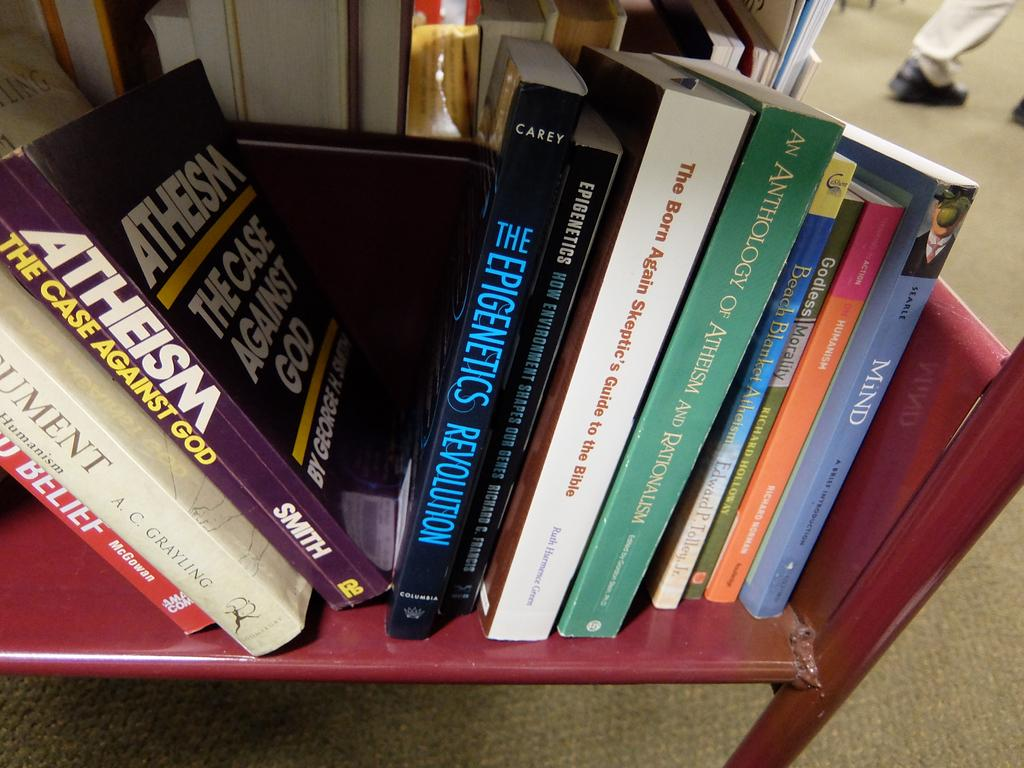Provide a one-sentence caption for the provided image. A stack of books about Athiesm sitting on a bookshelf. 